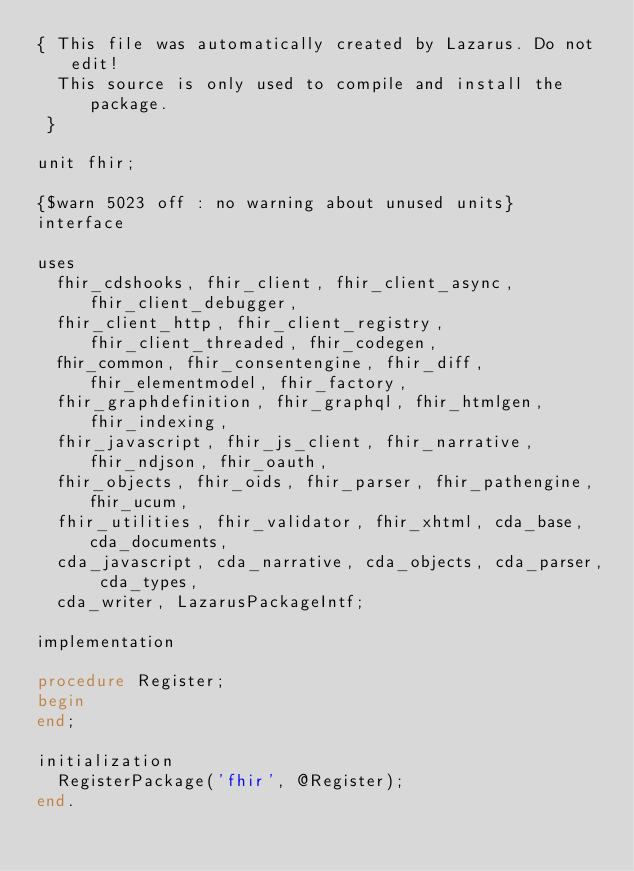<code> <loc_0><loc_0><loc_500><loc_500><_Pascal_>{ This file was automatically created by Lazarus. Do not edit!
  This source is only used to compile and install the package.
 }

unit fhir;

{$warn 5023 off : no warning about unused units}
interface

uses
  fhir_cdshooks, fhir_client, fhir_client_async, fhir_client_debugger, 
  fhir_client_http, fhir_client_registry, fhir_client_threaded, fhir_codegen, 
  fhir_common, fhir_consentengine, fhir_diff, fhir_elementmodel, fhir_factory, 
  fhir_graphdefinition, fhir_graphql, fhir_htmlgen, fhir_indexing, 
  fhir_javascript, fhir_js_client, fhir_narrative, fhir_ndjson, fhir_oauth, 
  fhir_objects, fhir_oids, fhir_parser, fhir_pathengine, fhir_ucum, 
  fhir_utilities, fhir_validator, fhir_xhtml, cda_base, cda_documents, 
  cda_javascript, cda_narrative, cda_objects, cda_parser, cda_types, 
  cda_writer, LazarusPackageIntf;

implementation

procedure Register;
begin
end;

initialization
  RegisterPackage('fhir', @Register);
end.
</code> 